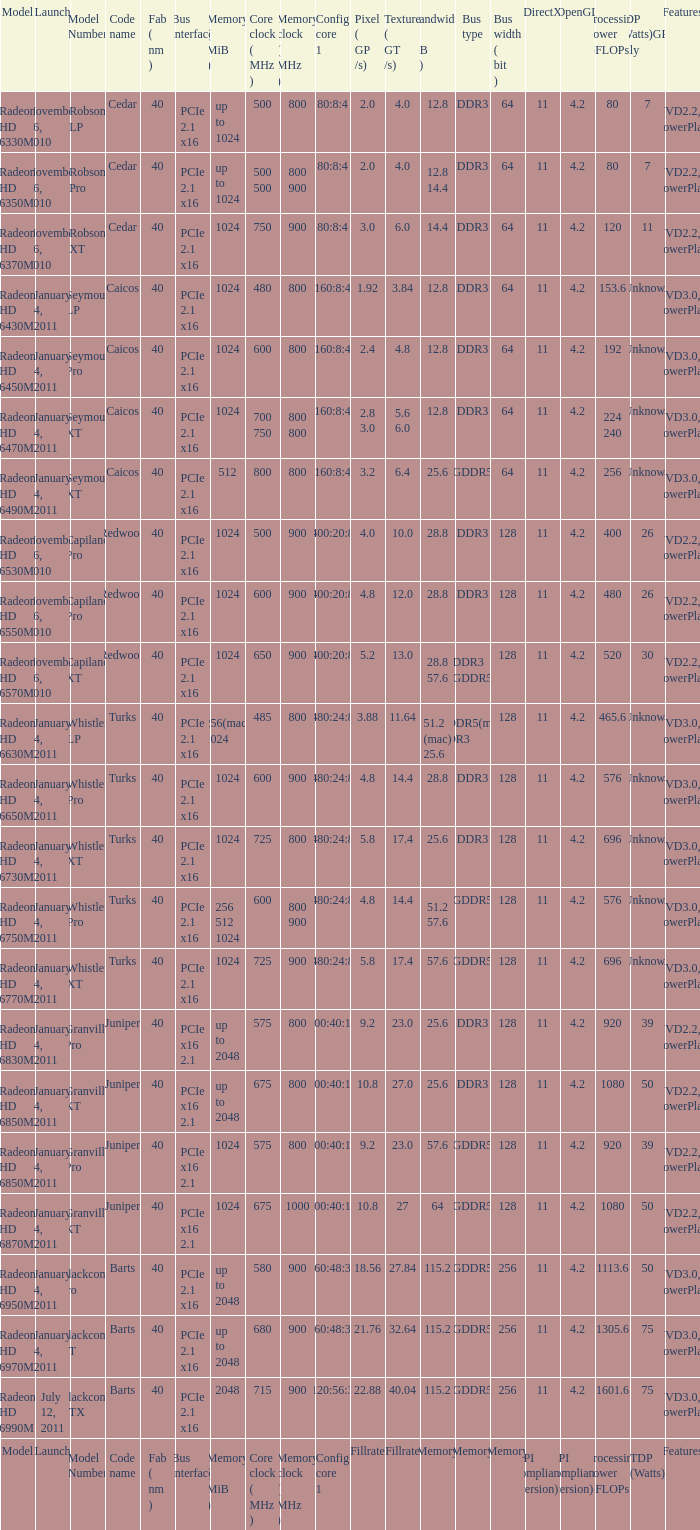How many values for bus width have a bandwidth of 25.6 and model number of Granville Pro? 1.0. 